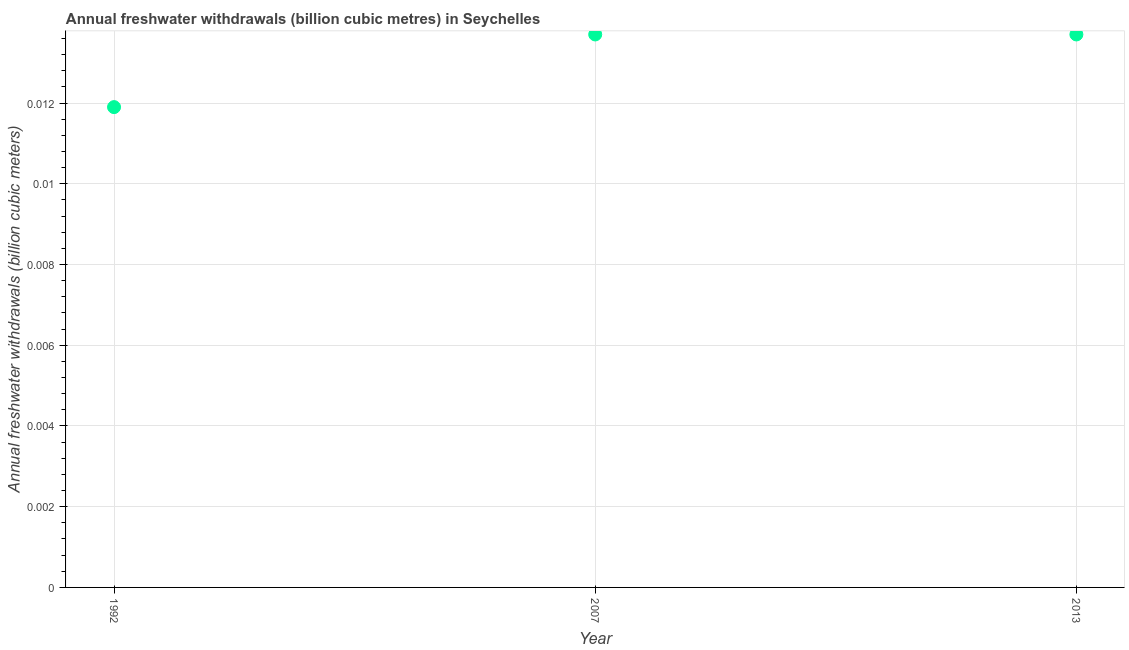What is the annual freshwater withdrawals in 2007?
Give a very brief answer. 0.01. Across all years, what is the maximum annual freshwater withdrawals?
Provide a succinct answer. 0.01. Across all years, what is the minimum annual freshwater withdrawals?
Keep it short and to the point. 0.01. What is the sum of the annual freshwater withdrawals?
Keep it short and to the point. 0.04. What is the difference between the annual freshwater withdrawals in 2007 and 2013?
Provide a short and direct response. 0. What is the average annual freshwater withdrawals per year?
Offer a very short reply. 0.01. What is the median annual freshwater withdrawals?
Offer a very short reply. 0.01. Do a majority of the years between 2013 and 2007 (inclusive) have annual freshwater withdrawals greater than 0.0056 billion cubic meters?
Your response must be concise. No. What is the ratio of the annual freshwater withdrawals in 1992 to that in 2007?
Make the answer very short. 0.87. Is the annual freshwater withdrawals in 1992 less than that in 2013?
Give a very brief answer. Yes. Is the difference between the annual freshwater withdrawals in 2007 and 2013 greater than the difference between any two years?
Offer a terse response. No. What is the difference between the highest and the lowest annual freshwater withdrawals?
Your answer should be very brief. 0. How many dotlines are there?
Offer a very short reply. 1. How many years are there in the graph?
Provide a succinct answer. 3. What is the difference between two consecutive major ticks on the Y-axis?
Give a very brief answer. 0. Does the graph contain any zero values?
Give a very brief answer. No. What is the title of the graph?
Offer a terse response. Annual freshwater withdrawals (billion cubic metres) in Seychelles. What is the label or title of the Y-axis?
Offer a terse response. Annual freshwater withdrawals (billion cubic meters). What is the Annual freshwater withdrawals (billion cubic meters) in 1992?
Offer a terse response. 0.01. What is the Annual freshwater withdrawals (billion cubic meters) in 2007?
Provide a short and direct response. 0.01. What is the Annual freshwater withdrawals (billion cubic meters) in 2013?
Provide a succinct answer. 0.01. What is the difference between the Annual freshwater withdrawals (billion cubic meters) in 1992 and 2007?
Offer a terse response. -0. What is the difference between the Annual freshwater withdrawals (billion cubic meters) in 1992 and 2013?
Your response must be concise. -0. What is the difference between the Annual freshwater withdrawals (billion cubic meters) in 2007 and 2013?
Give a very brief answer. 0. What is the ratio of the Annual freshwater withdrawals (billion cubic meters) in 1992 to that in 2007?
Make the answer very short. 0.87. What is the ratio of the Annual freshwater withdrawals (billion cubic meters) in 1992 to that in 2013?
Provide a short and direct response. 0.87. 